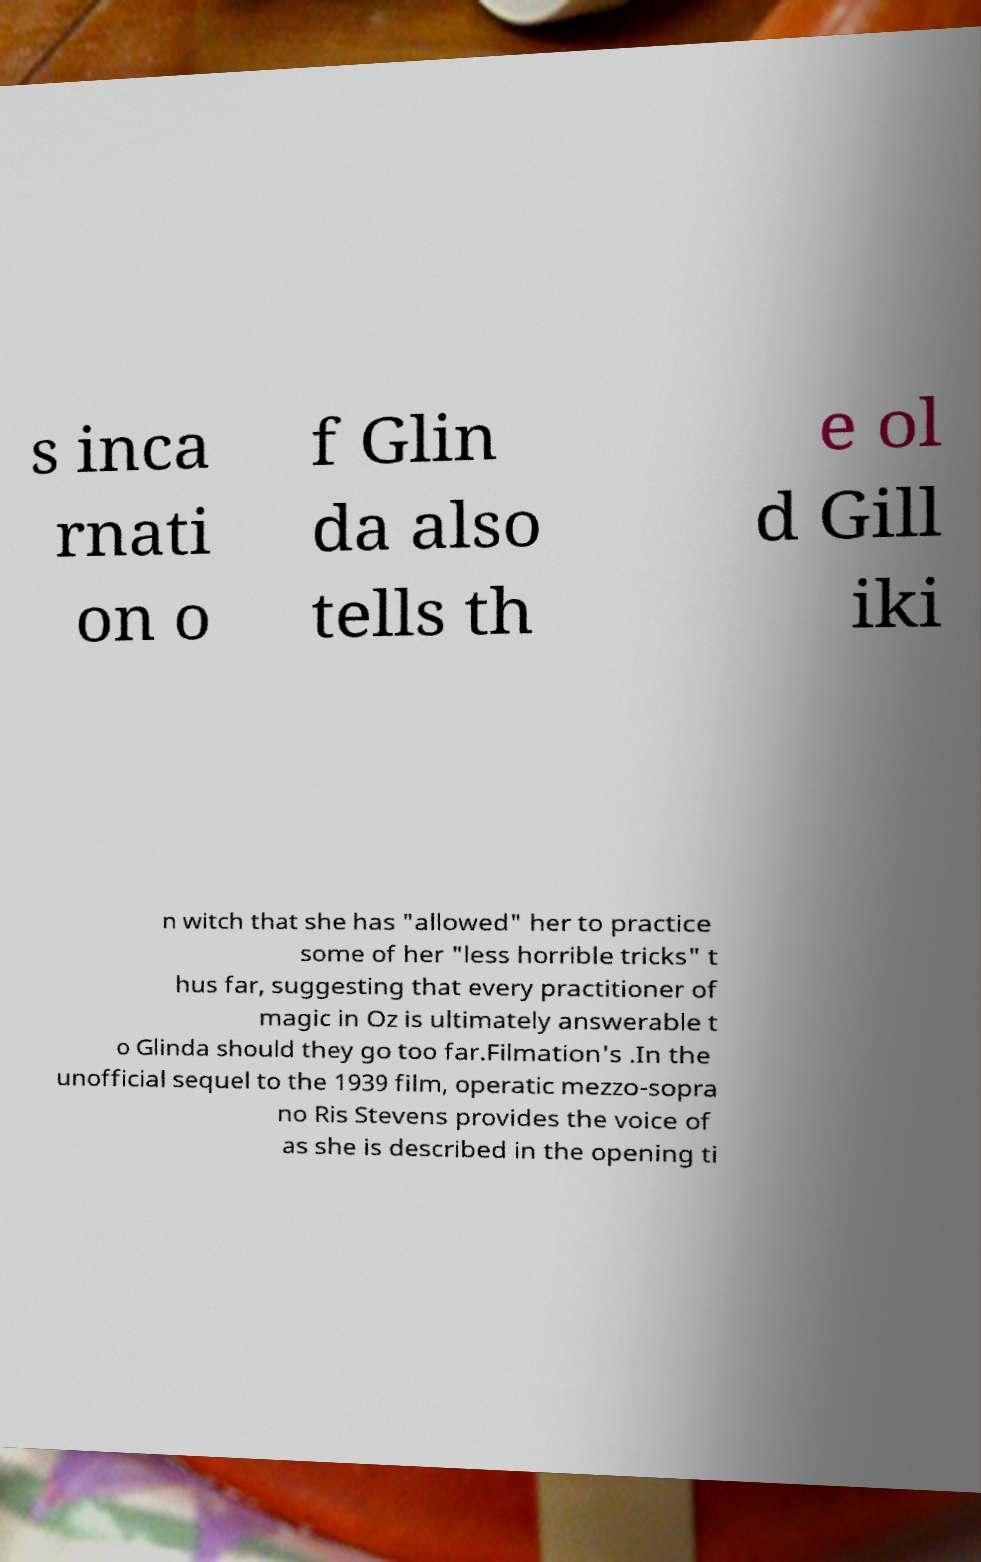Please identify and transcribe the text found in this image. s inca rnati on o f Glin da also tells th e ol d Gill iki n witch that she has "allowed" her to practice some of her "less horrible tricks" t hus far, suggesting that every practitioner of magic in Oz is ultimately answerable t o Glinda should they go too far.Filmation's .In the unofficial sequel to the 1939 film, operatic mezzo-sopra no Ris Stevens provides the voice of as she is described in the opening ti 